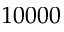Convert formula to latex. <formula><loc_0><loc_0><loc_500><loc_500>1 0 0 0 0</formula> 